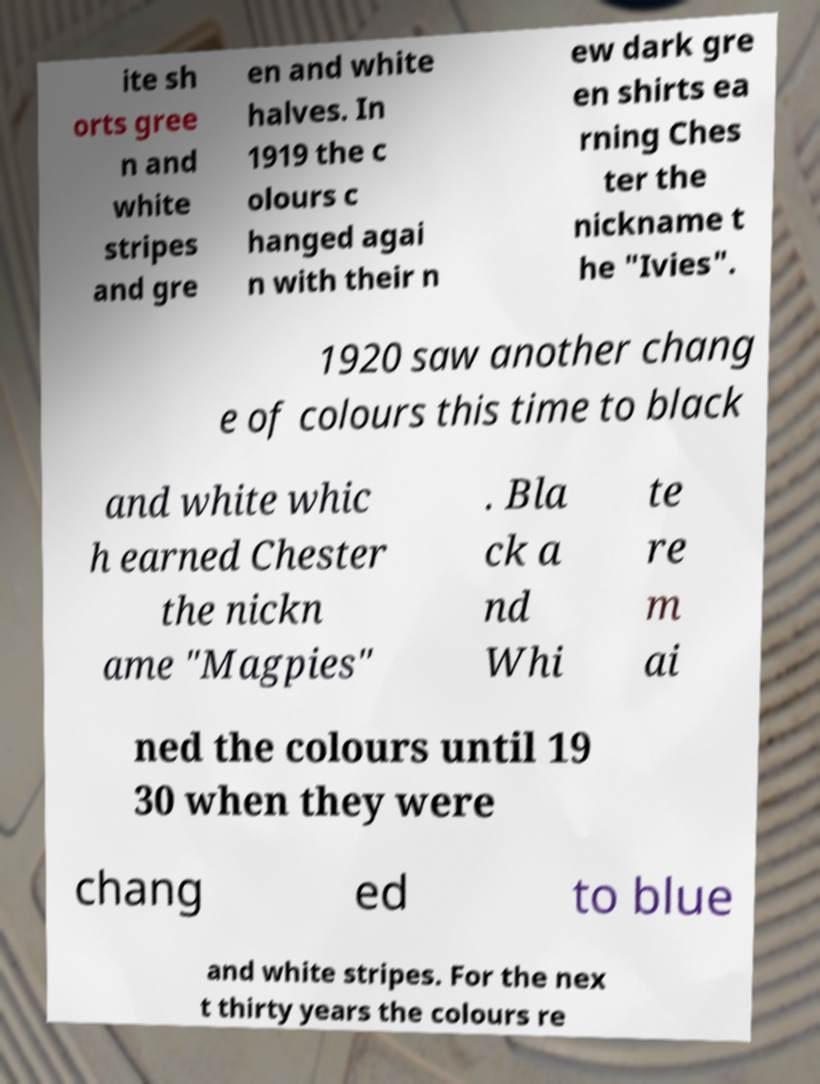For documentation purposes, I need the text within this image transcribed. Could you provide that? ite sh orts gree n and white stripes and gre en and white halves. In 1919 the c olours c hanged agai n with their n ew dark gre en shirts ea rning Ches ter the nickname t he "Ivies". 1920 saw another chang e of colours this time to black and white whic h earned Chester the nickn ame "Magpies" . Bla ck a nd Whi te re m ai ned the colours until 19 30 when they were chang ed to blue and white stripes. For the nex t thirty years the colours re 